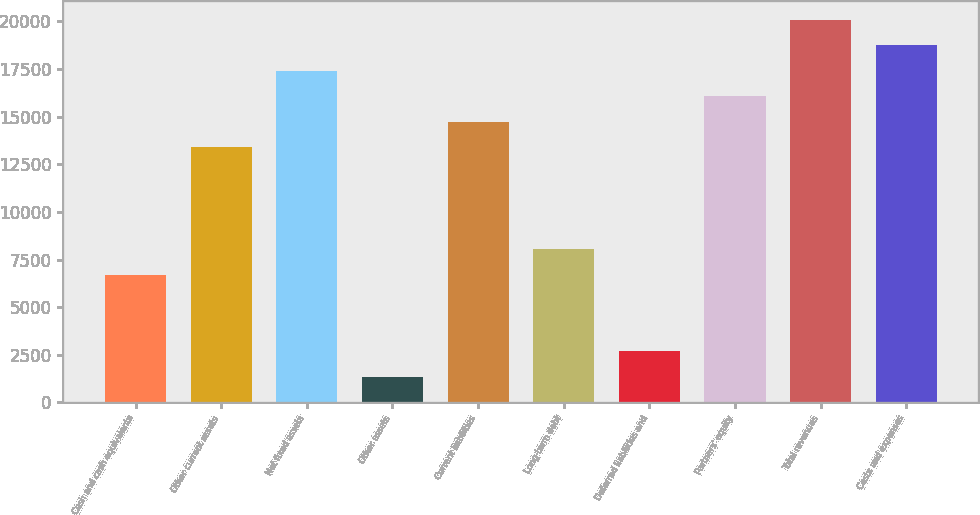Convert chart. <chart><loc_0><loc_0><loc_500><loc_500><bar_chart><fcel>Cash and cash equivalents<fcel>Other current assets<fcel>Net fixed assets<fcel>Other assets<fcel>Current liabilities<fcel>Long-term debt<fcel>Deferred liabilities and<fcel>Partners' equity<fcel>Total revenues<fcel>Costs and expenses<nl><fcel>6703.5<fcel>13396<fcel>17411.5<fcel>1349.5<fcel>14734.5<fcel>8042<fcel>2688<fcel>16073<fcel>20088.5<fcel>18750<nl></chart> 